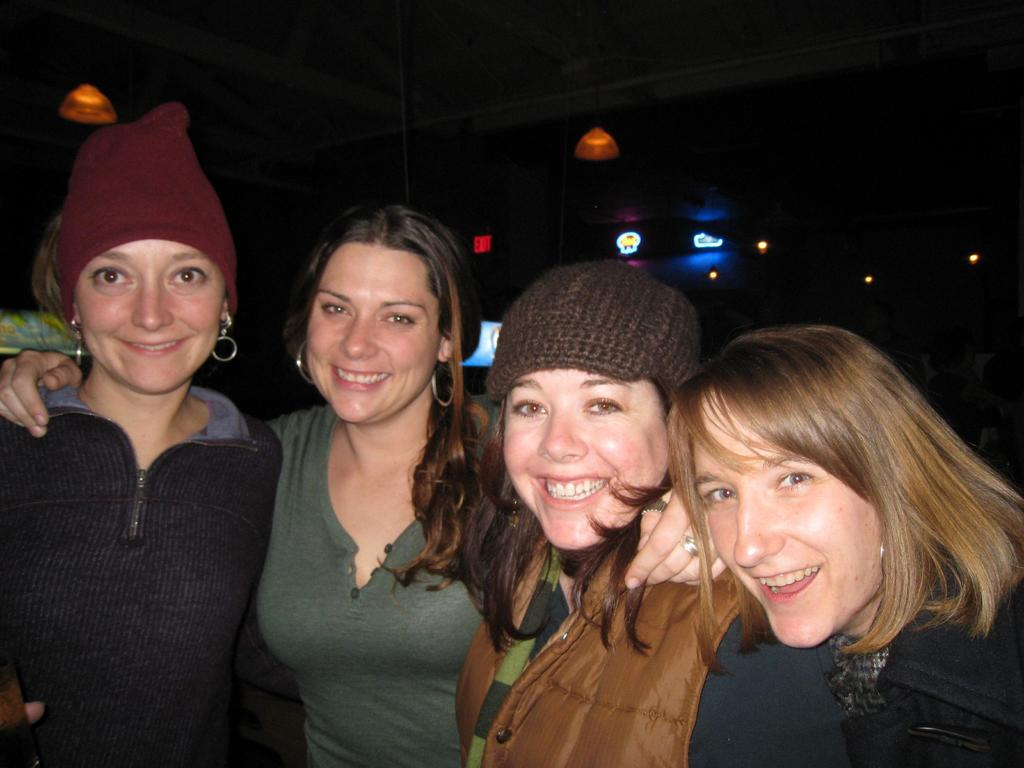How many people are present in the image? There are four people in the image. What expressions do the people have on their faces? The people are wearing smiles on their faces. What can be seen in the background of the image? There are lights visible in the background of the image. What type of ocean can be seen in the image? There is no ocean present in the image. What is the distribution of flesh among the people in the image? The image does not show any flesh or distribution of it; it only shows the people's faces with smiles. 